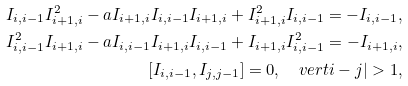<formula> <loc_0><loc_0><loc_500><loc_500>I _ { i , i - 1 } I _ { i + 1 , i } ^ { 2 } - a I _ { i + 1 , i } I _ { i , i - 1 } I _ { i + 1 , i } + I ^ { 2 } _ { i + 1 , i } I _ { i , i - 1 } = - I _ { i , i - 1 } , \\ I ^ { 2 } _ { i , i - 1 } I _ { i + 1 , i } - a I _ { i , i - 1 } I _ { i + 1 , i } I _ { i , i - 1 } + I _ { i + 1 , i } I ^ { 2 } _ { i , i - 1 } = - I _ { i + 1 , i } , \\ [ I _ { i , i - 1 } , I _ { j , j - 1 } ] = 0 , \quad v e r t i - j | > 1 ,</formula> 